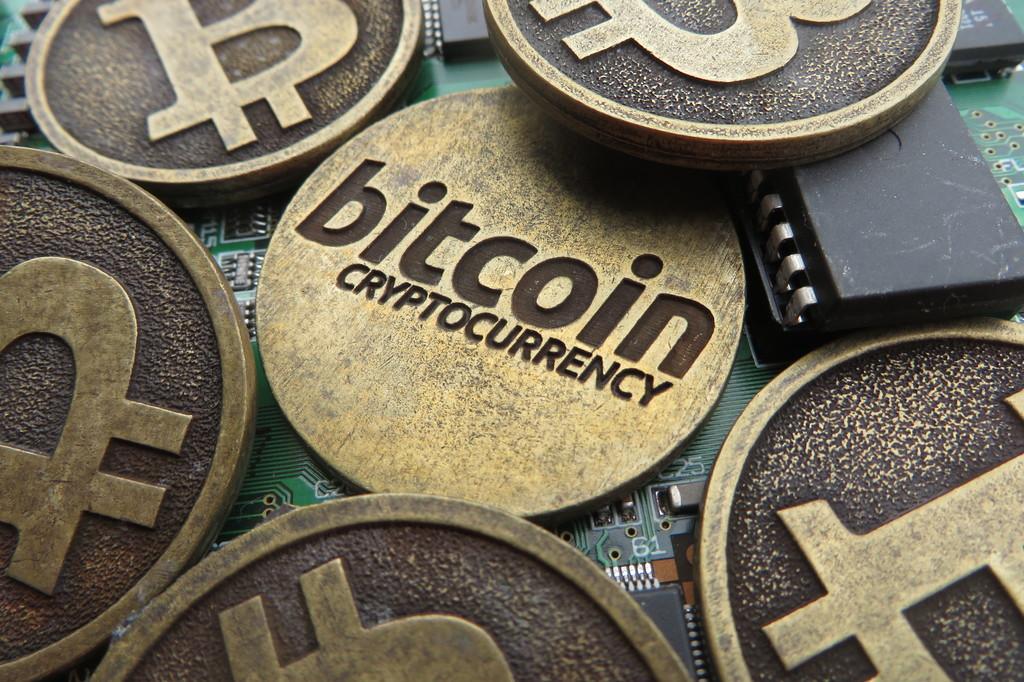Who is the sponsor of this team?
Give a very brief answer. Bitcoin. What brand is this cryptocurrency?
Make the answer very short. Bitcoin. 